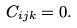Convert formula to latex. <formula><loc_0><loc_0><loc_500><loc_500>C _ { i j k } = 0 .</formula> 